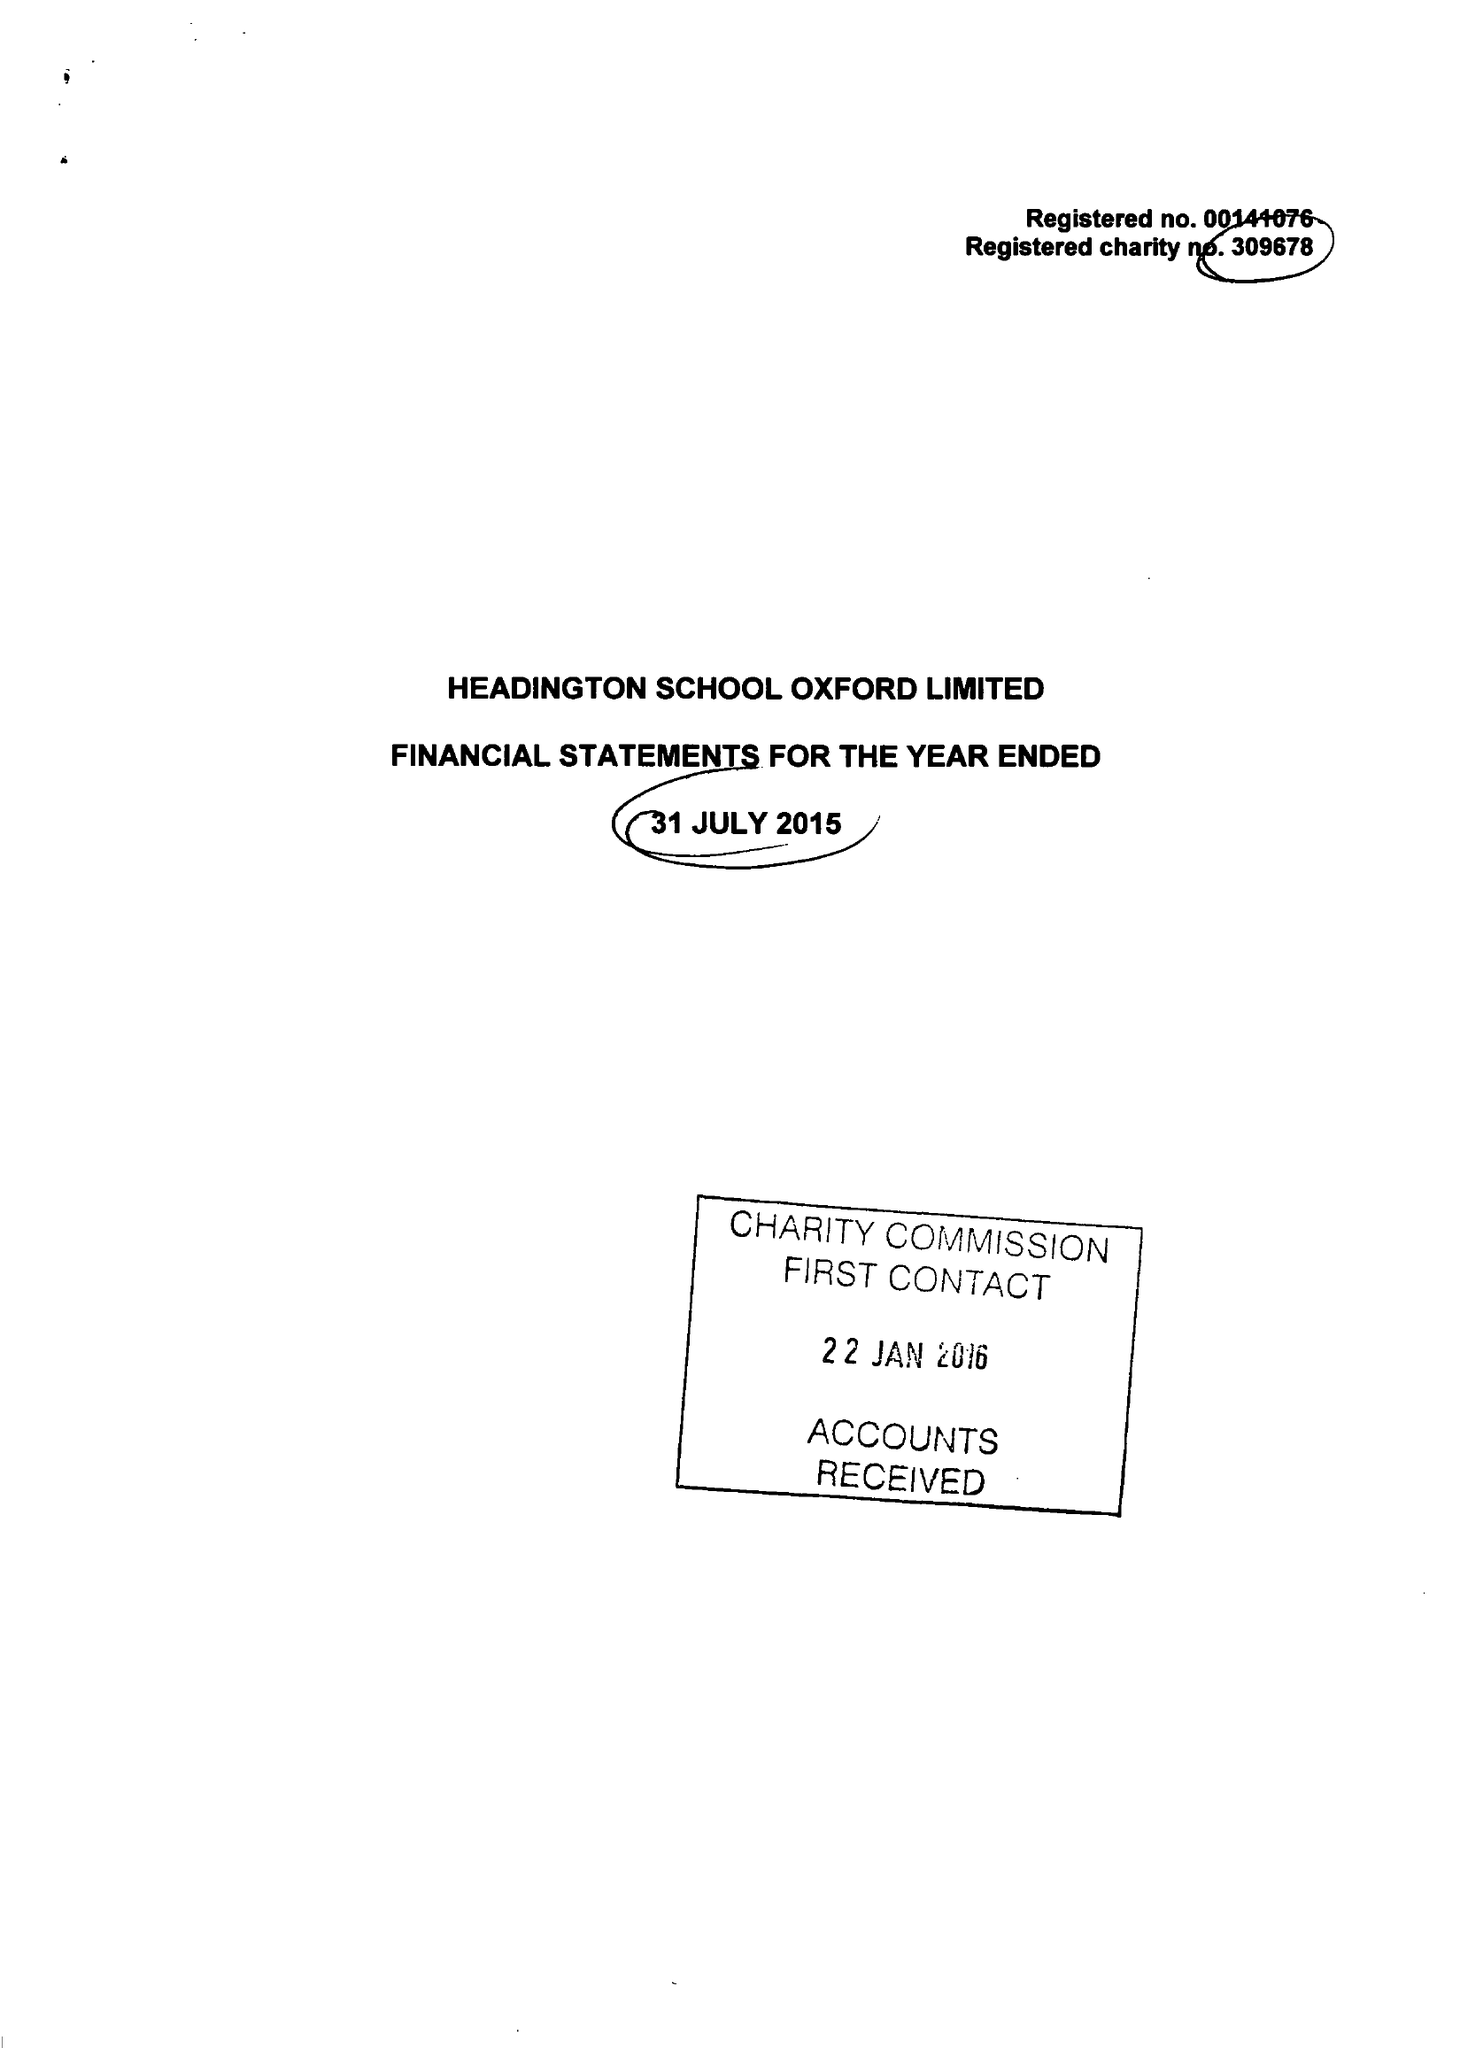What is the value for the report_date?
Answer the question using a single word or phrase. 2015-07-31 